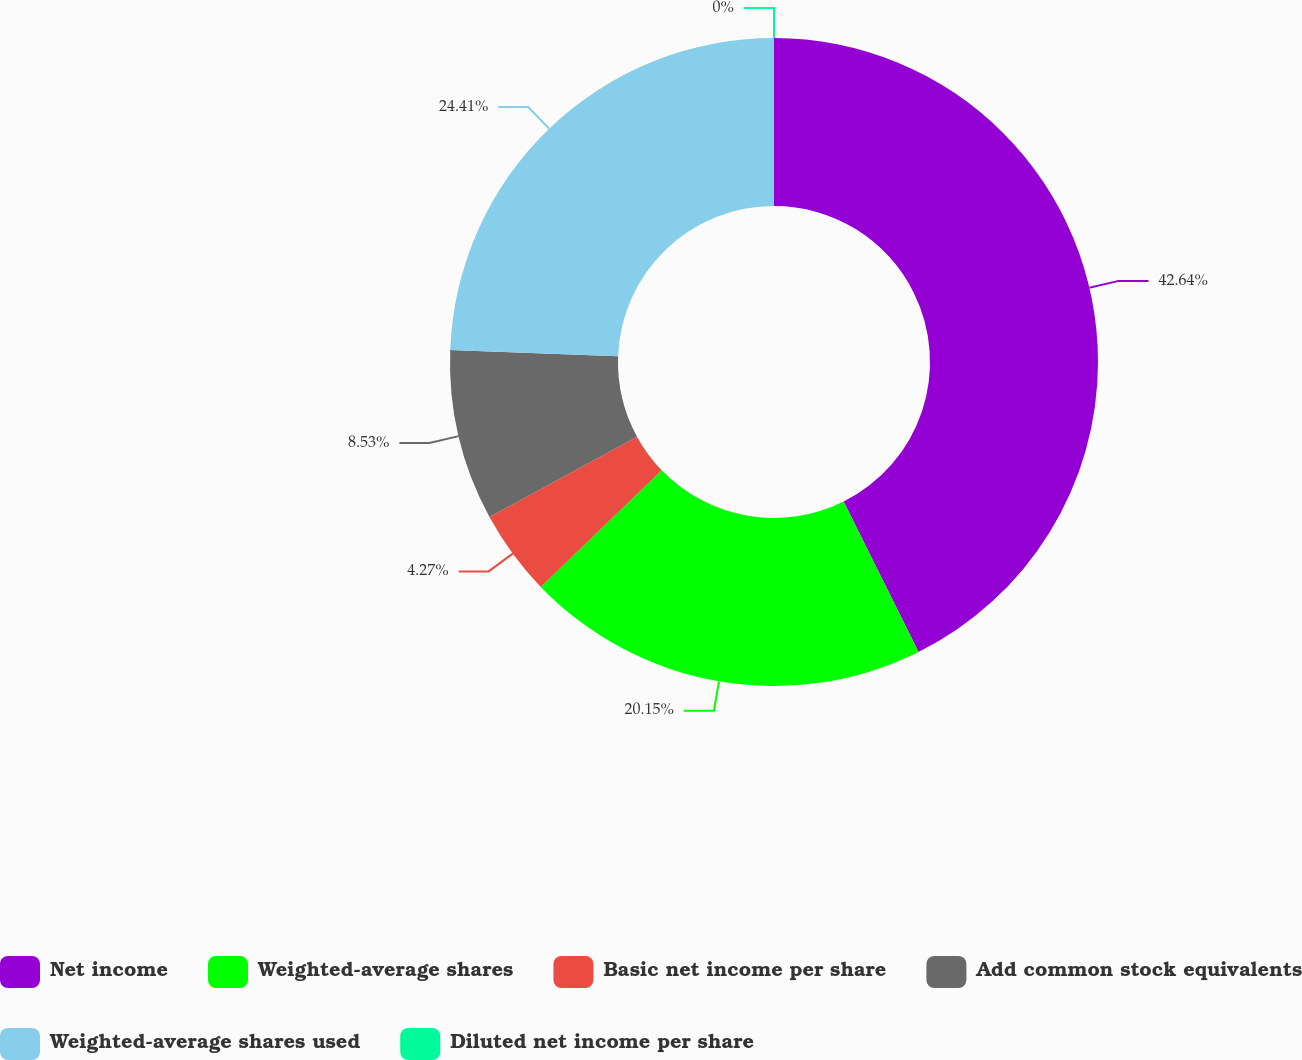Convert chart. <chart><loc_0><loc_0><loc_500><loc_500><pie_chart><fcel>Net income<fcel>Weighted-average shares<fcel>Basic net income per share<fcel>Add common stock equivalents<fcel>Weighted-average shares used<fcel>Diluted net income per share<nl><fcel>42.64%<fcel>20.15%<fcel>4.27%<fcel>8.53%<fcel>24.41%<fcel>0.0%<nl></chart> 